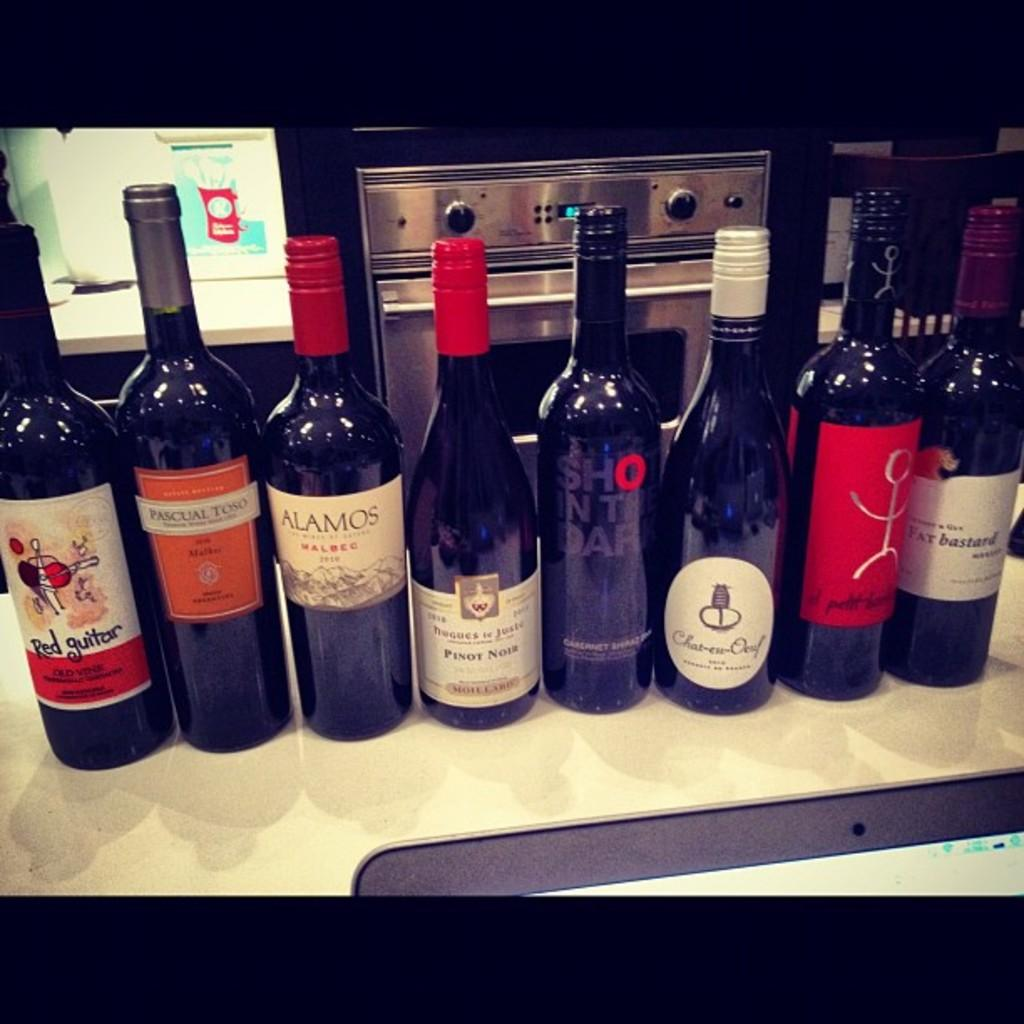Provide a one-sentence caption for the provided image. Many different wine bottles with one labeled Alamos. 